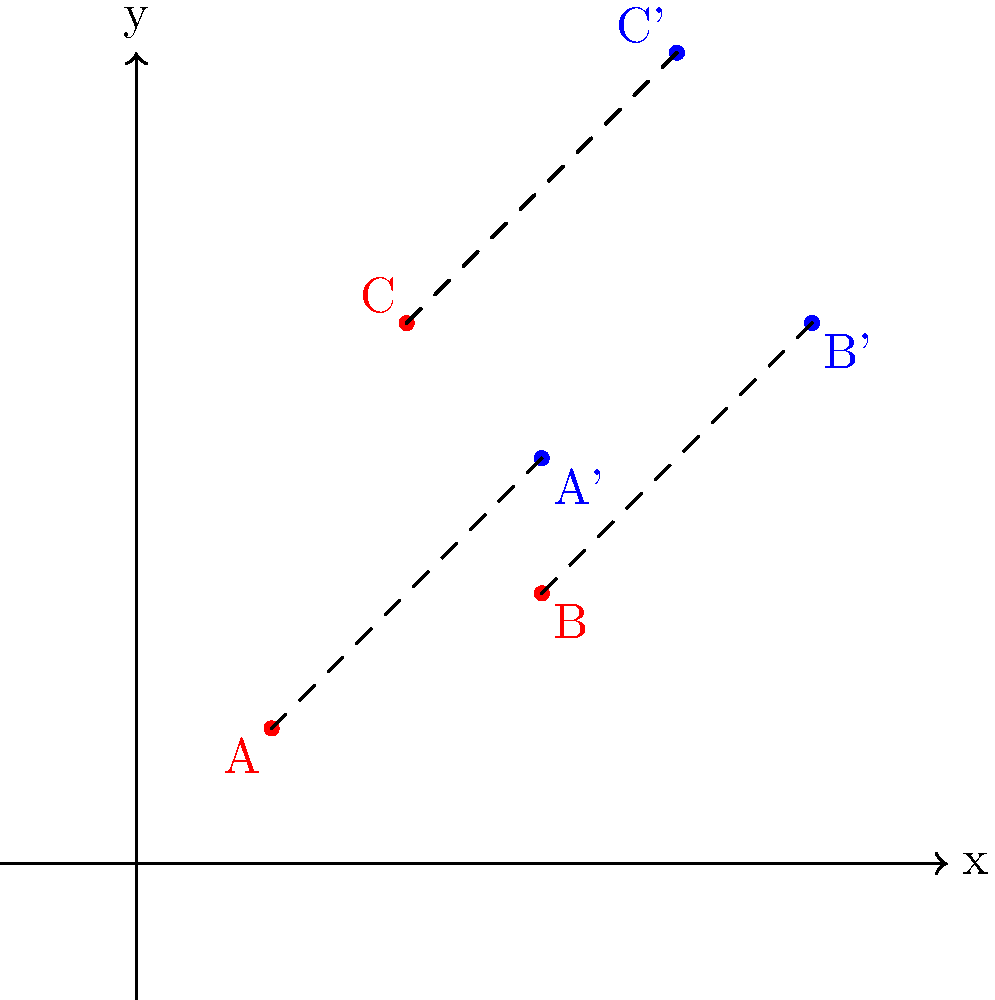As a history enthusiast familiar with local archaeological sites, you've been asked to help determine the translation vector that would move a set of artifacts from their current positions to their original locations. The diagram shows the current positions of three artifacts (A, B, and C) in red and their original positions (A', B', and C') in blue on a coordinate plane. What is the translation vector $(x,y)$ that would move the artifacts from their current positions to their original locations? To find the translation vector, we need to determine how far and in which direction each point moves. We can do this by comparing the coordinates of each original point with its corresponding translated point.

1. For point A:
   Original position: (1,1)
   Translated position: (3,3)
   Difference: (3-1, 3-1) = (2,2)

2. For point B:
   Original position: (3,2)
   Translated position: (5,4)
   Difference: (5-3, 4-2) = (2,2)

3. For point C:
   Original position: (2,4)
   Translated position: (4,6)
   Difference: (4-2, 6-4) = (2,2)

We can see that all points move by the same amount: 2 units to the right and 2 units up. This consistent movement confirms that this is indeed a translation.

Therefore, the translation vector that moves the artifacts from their current positions to their original locations is (2,2).
Answer: $(2,2)$ 